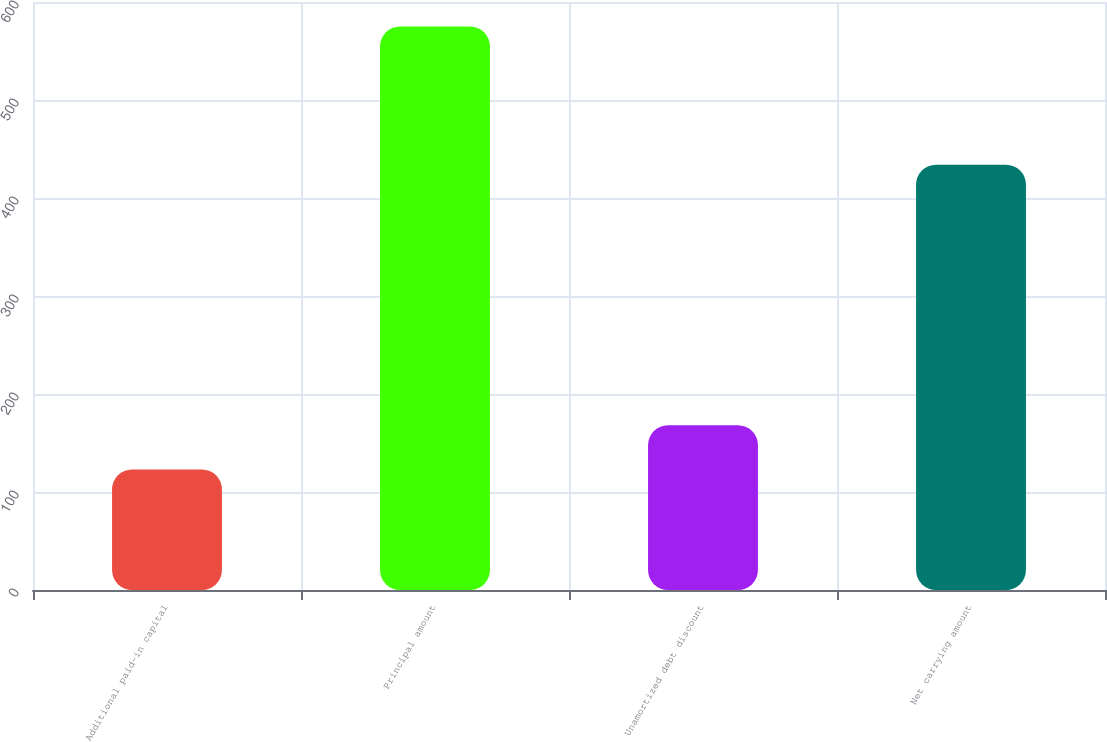Convert chart. <chart><loc_0><loc_0><loc_500><loc_500><bar_chart><fcel>Additional paid-in capital<fcel>Principal amount<fcel>Unamortized debt discount<fcel>Net carrying amount<nl><fcel>123<fcel>575<fcel>168.2<fcel>434<nl></chart> 